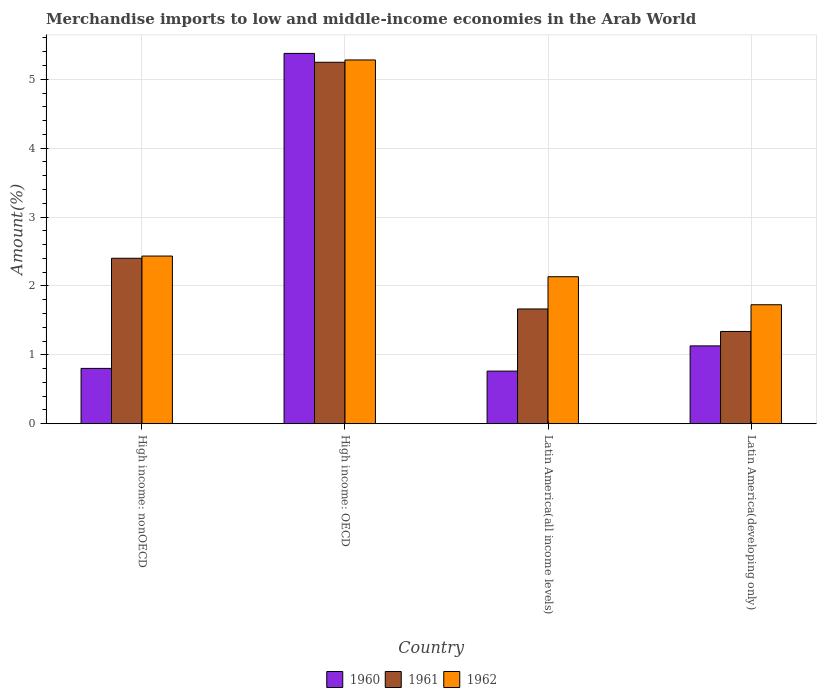How many different coloured bars are there?
Offer a very short reply. 3. Are the number of bars per tick equal to the number of legend labels?
Offer a terse response. Yes. Are the number of bars on each tick of the X-axis equal?
Your answer should be compact. Yes. How many bars are there on the 3rd tick from the right?
Keep it short and to the point. 3. What is the label of the 1st group of bars from the left?
Your response must be concise. High income: nonOECD. In how many cases, is the number of bars for a given country not equal to the number of legend labels?
Offer a very short reply. 0. What is the percentage of amount earned from merchandise imports in 1961 in High income: nonOECD?
Give a very brief answer. 2.4. Across all countries, what is the maximum percentage of amount earned from merchandise imports in 1961?
Offer a very short reply. 5.25. Across all countries, what is the minimum percentage of amount earned from merchandise imports in 1960?
Make the answer very short. 0.76. In which country was the percentage of amount earned from merchandise imports in 1962 maximum?
Your answer should be very brief. High income: OECD. In which country was the percentage of amount earned from merchandise imports in 1962 minimum?
Give a very brief answer. Latin America(developing only). What is the total percentage of amount earned from merchandise imports in 1960 in the graph?
Give a very brief answer. 8.07. What is the difference between the percentage of amount earned from merchandise imports in 1960 in High income: OECD and that in Latin America(all income levels)?
Your answer should be very brief. 4.61. What is the difference between the percentage of amount earned from merchandise imports in 1961 in High income: nonOECD and the percentage of amount earned from merchandise imports in 1962 in High income: OECD?
Offer a terse response. -2.88. What is the average percentage of amount earned from merchandise imports in 1961 per country?
Keep it short and to the point. 2.66. What is the difference between the percentage of amount earned from merchandise imports of/in 1962 and percentage of amount earned from merchandise imports of/in 1961 in High income: OECD?
Provide a succinct answer. 0.03. What is the ratio of the percentage of amount earned from merchandise imports in 1961 in High income: OECD to that in Latin America(developing only)?
Keep it short and to the point. 3.92. Is the difference between the percentage of amount earned from merchandise imports in 1962 in High income: OECD and Latin America(all income levels) greater than the difference between the percentage of amount earned from merchandise imports in 1961 in High income: OECD and Latin America(all income levels)?
Ensure brevity in your answer.  No. What is the difference between the highest and the second highest percentage of amount earned from merchandise imports in 1962?
Your answer should be very brief. 0.3. What is the difference between the highest and the lowest percentage of amount earned from merchandise imports in 1960?
Provide a succinct answer. 4.61. In how many countries, is the percentage of amount earned from merchandise imports in 1960 greater than the average percentage of amount earned from merchandise imports in 1960 taken over all countries?
Offer a terse response. 1. Is the sum of the percentage of amount earned from merchandise imports in 1962 in Latin America(all income levels) and Latin America(developing only) greater than the maximum percentage of amount earned from merchandise imports in 1960 across all countries?
Your answer should be compact. No. What does the 1st bar from the left in Latin America(developing only) represents?
Provide a succinct answer. 1960. How many bars are there?
Offer a very short reply. 12. Are all the bars in the graph horizontal?
Give a very brief answer. No. How many countries are there in the graph?
Provide a succinct answer. 4. Are the values on the major ticks of Y-axis written in scientific E-notation?
Ensure brevity in your answer.  No. Does the graph contain any zero values?
Give a very brief answer. No. Where does the legend appear in the graph?
Provide a succinct answer. Bottom center. How many legend labels are there?
Your response must be concise. 3. How are the legend labels stacked?
Offer a very short reply. Horizontal. What is the title of the graph?
Ensure brevity in your answer.  Merchandise imports to low and middle-income economies in the Arab World. What is the label or title of the Y-axis?
Offer a terse response. Amount(%). What is the Amount(%) of 1960 in High income: nonOECD?
Your answer should be compact. 0.8. What is the Amount(%) in 1961 in High income: nonOECD?
Your answer should be compact. 2.4. What is the Amount(%) in 1962 in High income: nonOECD?
Ensure brevity in your answer.  2.43. What is the Amount(%) of 1960 in High income: OECD?
Your response must be concise. 5.38. What is the Amount(%) of 1961 in High income: OECD?
Keep it short and to the point. 5.25. What is the Amount(%) of 1962 in High income: OECD?
Offer a very short reply. 5.28. What is the Amount(%) in 1960 in Latin America(all income levels)?
Offer a terse response. 0.76. What is the Amount(%) in 1961 in Latin America(all income levels)?
Offer a terse response. 1.67. What is the Amount(%) in 1962 in Latin America(all income levels)?
Offer a terse response. 2.13. What is the Amount(%) in 1960 in Latin America(developing only)?
Your answer should be very brief. 1.13. What is the Amount(%) of 1961 in Latin America(developing only)?
Your answer should be very brief. 1.34. What is the Amount(%) of 1962 in Latin America(developing only)?
Provide a succinct answer. 1.73. Across all countries, what is the maximum Amount(%) of 1960?
Your answer should be very brief. 5.38. Across all countries, what is the maximum Amount(%) in 1961?
Your answer should be very brief. 5.25. Across all countries, what is the maximum Amount(%) in 1962?
Give a very brief answer. 5.28. Across all countries, what is the minimum Amount(%) of 1960?
Your answer should be very brief. 0.76. Across all countries, what is the minimum Amount(%) in 1961?
Provide a succinct answer. 1.34. Across all countries, what is the minimum Amount(%) in 1962?
Your answer should be compact. 1.73. What is the total Amount(%) of 1960 in the graph?
Offer a very short reply. 8.07. What is the total Amount(%) of 1961 in the graph?
Your response must be concise. 10.65. What is the total Amount(%) in 1962 in the graph?
Provide a short and direct response. 11.57. What is the difference between the Amount(%) in 1960 in High income: nonOECD and that in High income: OECD?
Ensure brevity in your answer.  -4.57. What is the difference between the Amount(%) of 1961 in High income: nonOECD and that in High income: OECD?
Offer a terse response. -2.84. What is the difference between the Amount(%) in 1962 in High income: nonOECD and that in High income: OECD?
Ensure brevity in your answer.  -2.85. What is the difference between the Amount(%) in 1960 in High income: nonOECD and that in Latin America(all income levels)?
Make the answer very short. 0.04. What is the difference between the Amount(%) in 1961 in High income: nonOECD and that in Latin America(all income levels)?
Keep it short and to the point. 0.74. What is the difference between the Amount(%) in 1962 in High income: nonOECD and that in Latin America(all income levels)?
Your answer should be very brief. 0.3. What is the difference between the Amount(%) in 1960 in High income: nonOECD and that in Latin America(developing only)?
Your response must be concise. -0.33. What is the difference between the Amount(%) of 1961 in High income: nonOECD and that in Latin America(developing only)?
Your answer should be very brief. 1.06. What is the difference between the Amount(%) of 1962 in High income: nonOECD and that in Latin America(developing only)?
Offer a very short reply. 0.71. What is the difference between the Amount(%) of 1960 in High income: OECD and that in Latin America(all income levels)?
Your answer should be compact. 4.61. What is the difference between the Amount(%) of 1961 in High income: OECD and that in Latin America(all income levels)?
Give a very brief answer. 3.58. What is the difference between the Amount(%) in 1962 in High income: OECD and that in Latin America(all income levels)?
Provide a succinct answer. 3.15. What is the difference between the Amount(%) in 1960 in High income: OECD and that in Latin America(developing only)?
Give a very brief answer. 4.25. What is the difference between the Amount(%) of 1961 in High income: OECD and that in Latin America(developing only)?
Your response must be concise. 3.91. What is the difference between the Amount(%) in 1962 in High income: OECD and that in Latin America(developing only)?
Offer a terse response. 3.55. What is the difference between the Amount(%) of 1960 in Latin America(all income levels) and that in Latin America(developing only)?
Your answer should be very brief. -0.37. What is the difference between the Amount(%) of 1961 in Latin America(all income levels) and that in Latin America(developing only)?
Keep it short and to the point. 0.33. What is the difference between the Amount(%) in 1962 in Latin America(all income levels) and that in Latin America(developing only)?
Keep it short and to the point. 0.41. What is the difference between the Amount(%) in 1960 in High income: nonOECD and the Amount(%) in 1961 in High income: OECD?
Offer a very short reply. -4.44. What is the difference between the Amount(%) of 1960 in High income: nonOECD and the Amount(%) of 1962 in High income: OECD?
Offer a very short reply. -4.48. What is the difference between the Amount(%) of 1961 in High income: nonOECD and the Amount(%) of 1962 in High income: OECD?
Ensure brevity in your answer.  -2.88. What is the difference between the Amount(%) in 1960 in High income: nonOECD and the Amount(%) in 1961 in Latin America(all income levels)?
Provide a short and direct response. -0.86. What is the difference between the Amount(%) in 1960 in High income: nonOECD and the Amount(%) in 1962 in Latin America(all income levels)?
Provide a short and direct response. -1.33. What is the difference between the Amount(%) of 1961 in High income: nonOECD and the Amount(%) of 1962 in Latin America(all income levels)?
Provide a short and direct response. 0.27. What is the difference between the Amount(%) in 1960 in High income: nonOECD and the Amount(%) in 1961 in Latin America(developing only)?
Your response must be concise. -0.54. What is the difference between the Amount(%) of 1960 in High income: nonOECD and the Amount(%) of 1962 in Latin America(developing only)?
Provide a short and direct response. -0.92. What is the difference between the Amount(%) of 1961 in High income: nonOECD and the Amount(%) of 1962 in Latin America(developing only)?
Make the answer very short. 0.67. What is the difference between the Amount(%) of 1960 in High income: OECD and the Amount(%) of 1961 in Latin America(all income levels)?
Make the answer very short. 3.71. What is the difference between the Amount(%) in 1960 in High income: OECD and the Amount(%) in 1962 in Latin America(all income levels)?
Provide a succinct answer. 3.24. What is the difference between the Amount(%) in 1961 in High income: OECD and the Amount(%) in 1962 in Latin America(all income levels)?
Provide a succinct answer. 3.11. What is the difference between the Amount(%) in 1960 in High income: OECD and the Amount(%) in 1961 in Latin America(developing only)?
Ensure brevity in your answer.  4.04. What is the difference between the Amount(%) of 1960 in High income: OECD and the Amount(%) of 1962 in Latin America(developing only)?
Provide a succinct answer. 3.65. What is the difference between the Amount(%) in 1961 in High income: OECD and the Amount(%) in 1962 in Latin America(developing only)?
Make the answer very short. 3.52. What is the difference between the Amount(%) of 1960 in Latin America(all income levels) and the Amount(%) of 1961 in Latin America(developing only)?
Provide a succinct answer. -0.58. What is the difference between the Amount(%) of 1960 in Latin America(all income levels) and the Amount(%) of 1962 in Latin America(developing only)?
Keep it short and to the point. -0.96. What is the difference between the Amount(%) in 1961 in Latin America(all income levels) and the Amount(%) in 1962 in Latin America(developing only)?
Offer a terse response. -0.06. What is the average Amount(%) of 1960 per country?
Provide a succinct answer. 2.02. What is the average Amount(%) of 1961 per country?
Provide a succinct answer. 2.66. What is the average Amount(%) in 1962 per country?
Offer a terse response. 2.89. What is the difference between the Amount(%) in 1960 and Amount(%) in 1961 in High income: nonOECD?
Offer a very short reply. -1.6. What is the difference between the Amount(%) in 1960 and Amount(%) in 1962 in High income: nonOECD?
Your answer should be very brief. -1.63. What is the difference between the Amount(%) in 1961 and Amount(%) in 1962 in High income: nonOECD?
Keep it short and to the point. -0.03. What is the difference between the Amount(%) of 1960 and Amount(%) of 1961 in High income: OECD?
Ensure brevity in your answer.  0.13. What is the difference between the Amount(%) of 1960 and Amount(%) of 1962 in High income: OECD?
Your answer should be compact. 0.1. What is the difference between the Amount(%) in 1961 and Amount(%) in 1962 in High income: OECD?
Offer a terse response. -0.03. What is the difference between the Amount(%) in 1960 and Amount(%) in 1961 in Latin America(all income levels)?
Keep it short and to the point. -0.9. What is the difference between the Amount(%) of 1960 and Amount(%) of 1962 in Latin America(all income levels)?
Your answer should be compact. -1.37. What is the difference between the Amount(%) of 1961 and Amount(%) of 1962 in Latin America(all income levels)?
Give a very brief answer. -0.47. What is the difference between the Amount(%) in 1960 and Amount(%) in 1961 in Latin America(developing only)?
Your answer should be compact. -0.21. What is the difference between the Amount(%) in 1960 and Amount(%) in 1962 in Latin America(developing only)?
Your response must be concise. -0.6. What is the difference between the Amount(%) in 1961 and Amount(%) in 1962 in Latin America(developing only)?
Keep it short and to the point. -0.39. What is the ratio of the Amount(%) in 1960 in High income: nonOECD to that in High income: OECD?
Keep it short and to the point. 0.15. What is the ratio of the Amount(%) of 1961 in High income: nonOECD to that in High income: OECD?
Give a very brief answer. 0.46. What is the ratio of the Amount(%) in 1962 in High income: nonOECD to that in High income: OECD?
Make the answer very short. 0.46. What is the ratio of the Amount(%) in 1960 in High income: nonOECD to that in Latin America(all income levels)?
Your answer should be compact. 1.05. What is the ratio of the Amount(%) in 1961 in High income: nonOECD to that in Latin America(all income levels)?
Provide a succinct answer. 1.44. What is the ratio of the Amount(%) of 1962 in High income: nonOECD to that in Latin America(all income levels)?
Offer a terse response. 1.14. What is the ratio of the Amount(%) of 1960 in High income: nonOECD to that in Latin America(developing only)?
Your response must be concise. 0.71. What is the ratio of the Amount(%) of 1961 in High income: nonOECD to that in Latin America(developing only)?
Provide a succinct answer. 1.79. What is the ratio of the Amount(%) in 1962 in High income: nonOECD to that in Latin America(developing only)?
Provide a short and direct response. 1.41. What is the ratio of the Amount(%) in 1960 in High income: OECD to that in Latin America(all income levels)?
Provide a short and direct response. 7.04. What is the ratio of the Amount(%) in 1961 in High income: OECD to that in Latin America(all income levels)?
Offer a very short reply. 3.15. What is the ratio of the Amount(%) of 1962 in High income: OECD to that in Latin America(all income levels)?
Provide a succinct answer. 2.47. What is the ratio of the Amount(%) of 1960 in High income: OECD to that in Latin America(developing only)?
Ensure brevity in your answer.  4.76. What is the ratio of the Amount(%) of 1961 in High income: OECD to that in Latin America(developing only)?
Your response must be concise. 3.92. What is the ratio of the Amount(%) of 1962 in High income: OECD to that in Latin America(developing only)?
Offer a very short reply. 3.06. What is the ratio of the Amount(%) of 1960 in Latin America(all income levels) to that in Latin America(developing only)?
Provide a succinct answer. 0.68. What is the ratio of the Amount(%) in 1961 in Latin America(all income levels) to that in Latin America(developing only)?
Ensure brevity in your answer.  1.24. What is the ratio of the Amount(%) in 1962 in Latin America(all income levels) to that in Latin America(developing only)?
Offer a terse response. 1.24. What is the difference between the highest and the second highest Amount(%) in 1960?
Offer a very short reply. 4.25. What is the difference between the highest and the second highest Amount(%) in 1961?
Offer a very short reply. 2.84. What is the difference between the highest and the second highest Amount(%) in 1962?
Ensure brevity in your answer.  2.85. What is the difference between the highest and the lowest Amount(%) of 1960?
Your answer should be compact. 4.61. What is the difference between the highest and the lowest Amount(%) in 1961?
Ensure brevity in your answer.  3.91. What is the difference between the highest and the lowest Amount(%) of 1962?
Give a very brief answer. 3.55. 